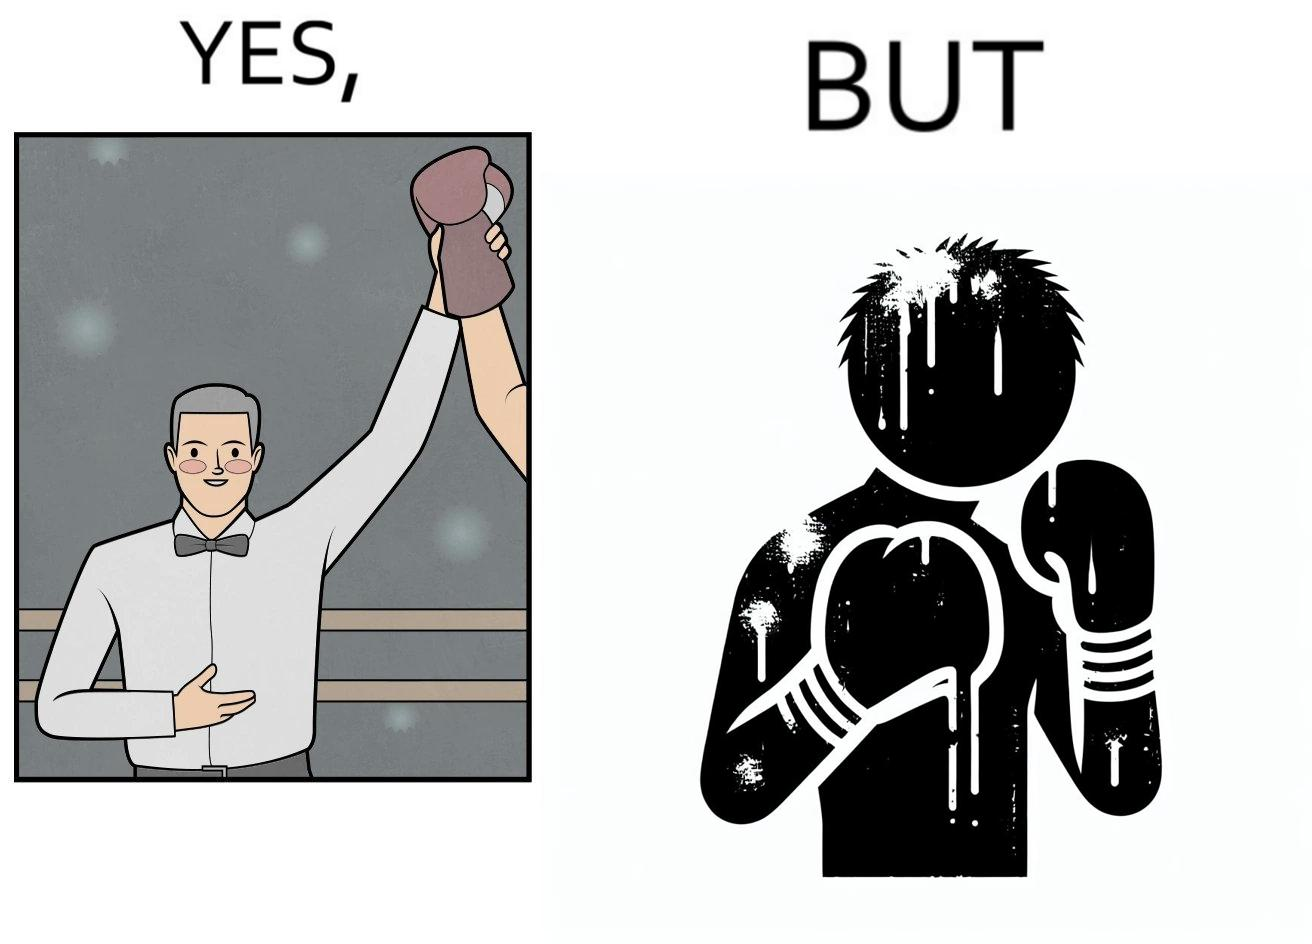Describe the contrast between the left and right parts of this image. In the left part of the image: a referee announcing the winner of a boxing match. In the right part of the image: a bruised boxer. 